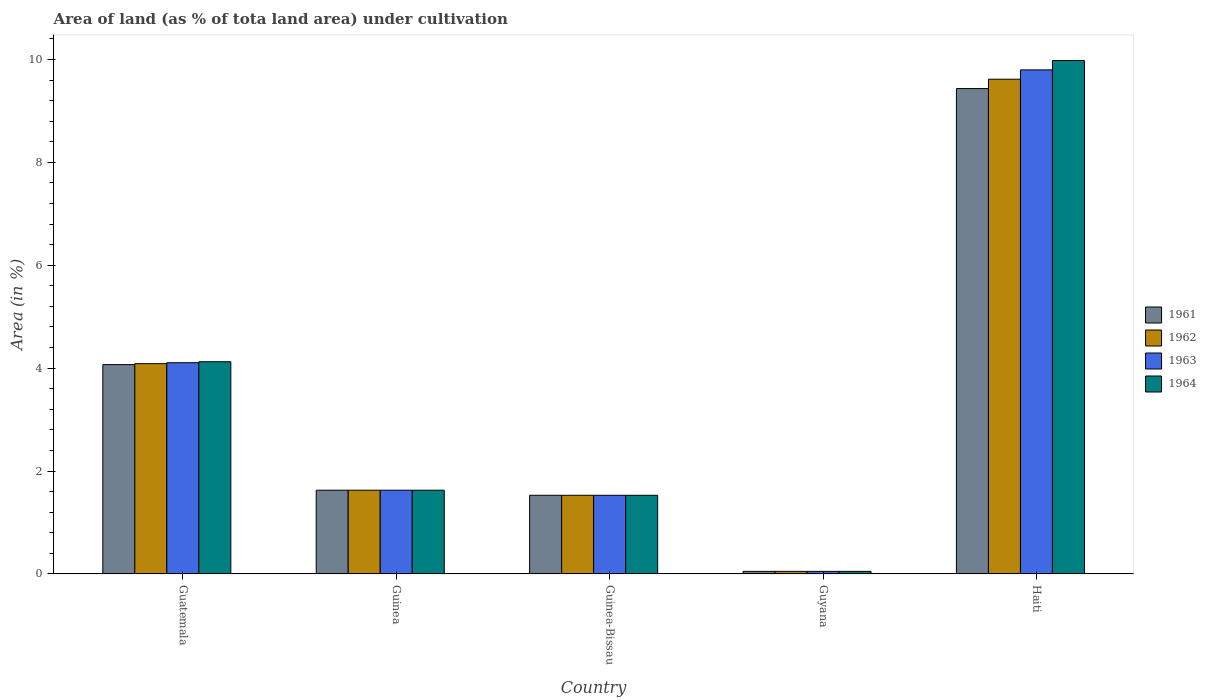Are the number of bars on each tick of the X-axis equal?
Offer a terse response. Yes. How many bars are there on the 2nd tick from the right?
Give a very brief answer. 4. What is the label of the 5th group of bars from the left?
Offer a terse response. Haiti. What is the percentage of land under cultivation in 1961 in Guinea-Bissau?
Your answer should be compact. 1.53. Across all countries, what is the maximum percentage of land under cultivation in 1962?
Your answer should be very brief. 9.62. Across all countries, what is the minimum percentage of land under cultivation in 1961?
Keep it short and to the point. 0.05. In which country was the percentage of land under cultivation in 1962 maximum?
Make the answer very short. Haiti. In which country was the percentage of land under cultivation in 1961 minimum?
Provide a short and direct response. Guyana. What is the total percentage of land under cultivation in 1962 in the graph?
Ensure brevity in your answer.  16.91. What is the difference between the percentage of land under cultivation in 1961 in Guinea and that in Haiti?
Keep it short and to the point. -7.81. What is the difference between the percentage of land under cultivation in 1962 in Guyana and the percentage of land under cultivation in 1964 in Guinea-Bissau?
Your response must be concise. -1.48. What is the average percentage of land under cultivation in 1963 per country?
Provide a short and direct response. 3.42. What is the difference between the percentage of land under cultivation of/in 1961 and percentage of land under cultivation of/in 1962 in Guatemala?
Give a very brief answer. -0.02. What is the ratio of the percentage of land under cultivation in 1964 in Guinea to that in Guyana?
Offer a terse response. 32.02. Is the difference between the percentage of land under cultivation in 1961 in Guinea and Haiti greater than the difference between the percentage of land under cultivation in 1962 in Guinea and Haiti?
Give a very brief answer. Yes. What is the difference between the highest and the second highest percentage of land under cultivation in 1964?
Your response must be concise. 5.85. What is the difference between the highest and the lowest percentage of land under cultivation in 1961?
Provide a succinct answer. 9.38. In how many countries, is the percentage of land under cultivation in 1961 greater than the average percentage of land under cultivation in 1961 taken over all countries?
Give a very brief answer. 2. Is it the case that in every country, the sum of the percentage of land under cultivation in 1962 and percentage of land under cultivation in 1961 is greater than the sum of percentage of land under cultivation in 1964 and percentage of land under cultivation in 1963?
Keep it short and to the point. No. Is it the case that in every country, the sum of the percentage of land under cultivation in 1963 and percentage of land under cultivation in 1964 is greater than the percentage of land under cultivation in 1961?
Offer a terse response. Yes. Does the graph contain any zero values?
Your answer should be very brief. No. What is the title of the graph?
Provide a short and direct response. Area of land (as % of tota land area) under cultivation. What is the label or title of the X-axis?
Provide a short and direct response. Country. What is the label or title of the Y-axis?
Keep it short and to the point. Area (in %). What is the Area (in %) of 1961 in Guatemala?
Your answer should be very brief. 4.07. What is the Area (in %) in 1962 in Guatemala?
Provide a succinct answer. 4.09. What is the Area (in %) in 1963 in Guatemala?
Give a very brief answer. 4.11. What is the Area (in %) in 1964 in Guatemala?
Keep it short and to the point. 4.12. What is the Area (in %) of 1961 in Guinea?
Ensure brevity in your answer.  1.63. What is the Area (in %) in 1962 in Guinea?
Ensure brevity in your answer.  1.63. What is the Area (in %) of 1963 in Guinea?
Keep it short and to the point. 1.63. What is the Area (in %) of 1964 in Guinea?
Offer a terse response. 1.63. What is the Area (in %) of 1961 in Guinea-Bissau?
Offer a very short reply. 1.53. What is the Area (in %) of 1962 in Guinea-Bissau?
Provide a succinct answer. 1.53. What is the Area (in %) of 1963 in Guinea-Bissau?
Your answer should be very brief. 1.53. What is the Area (in %) in 1964 in Guinea-Bissau?
Ensure brevity in your answer.  1.53. What is the Area (in %) in 1961 in Guyana?
Keep it short and to the point. 0.05. What is the Area (in %) in 1962 in Guyana?
Your answer should be compact. 0.05. What is the Area (in %) in 1963 in Guyana?
Offer a terse response. 0.05. What is the Area (in %) in 1964 in Guyana?
Offer a terse response. 0.05. What is the Area (in %) in 1961 in Haiti?
Ensure brevity in your answer.  9.43. What is the Area (in %) in 1962 in Haiti?
Offer a very short reply. 9.62. What is the Area (in %) of 1963 in Haiti?
Keep it short and to the point. 9.8. What is the Area (in %) in 1964 in Haiti?
Give a very brief answer. 9.98. Across all countries, what is the maximum Area (in %) of 1961?
Offer a very short reply. 9.43. Across all countries, what is the maximum Area (in %) of 1962?
Your response must be concise. 9.62. Across all countries, what is the maximum Area (in %) of 1963?
Your answer should be very brief. 9.8. Across all countries, what is the maximum Area (in %) in 1964?
Keep it short and to the point. 9.98. Across all countries, what is the minimum Area (in %) in 1961?
Provide a short and direct response. 0.05. Across all countries, what is the minimum Area (in %) in 1962?
Give a very brief answer. 0.05. Across all countries, what is the minimum Area (in %) of 1963?
Give a very brief answer. 0.05. Across all countries, what is the minimum Area (in %) in 1964?
Ensure brevity in your answer.  0.05. What is the total Area (in %) in 1961 in the graph?
Offer a very short reply. 16.71. What is the total Area (in %) of 1962 in the graph?
Provide a succinct answer. 16.91. What is the total Area (in %) of 1963 in the graph?
Offer a very short reply. 17.11. What is the total Area (in %) of 1964 in the graph?
Give a very brief answer. 17.31. What is the difference between the Area (in %) in 1961 in Guatemala and that in Guinea?
Give a very brief answer. 2.44. What is the difference between the Area (in %) of 1962 in Guatemala and that in Guinea?
Offer a very short reply. 2.46. What is the difference between the Area (in %) in 1963 in Guatemala and that in Guinea?
Your answer should be compact. 2.48. What is the difference between the Area (in %) in 1964 in Guatemala and that in Guinea?
Your answer should be very brief. 2.5. What is the difference between the Area (in %) of 1961 in Guatemala and that in Guinea-Bissau?
Offer a very short reply. 2.54. What is the difference between the Area (in %) in 1962 in Guatemala and that in Guinea-Bissau?
Give a very brief answer. 2.56. What is the difference between the Area (in %) in 1963 in Guatemala and that in Guinea-Bissau?
Offer a terse response. 2.58. What is the difference between the Area (in %) in 1964 in Guatemala and that in Guinea-Bissau?
Your answer should be compact. 2.6. What is the difference between the Area (in %) of 1961 in Guatemala and that in Guyana?
Provide a succinct answer. 4.02. What is the difference between the Area (in %) in 1962 in Guatemala and that in Guyana?
Your response must be concise. 4.04. What is the difference between the Area (in %) in 1963 in Guatemala and that in Guyana?
Your answer should be compact. 4.06. What is the difference between the Area (in %) of 1964 in Guatemala and that in Guyana?
Your response must be concise. 4.07. What is the difference between the Area (in %) of 1961 in Guatemala and that in Haiti?
Offer a terse response. -5.37. What is the difference between the Area (in %) in 1962 in Guatemala and that in Haiti?
Your answer should be very brief. -5.53. What is the difference between the Area (in %) in 1963 in Guatemala and that in Haiti?
Your answer should be compact. -5.69. What is the difference between the Area (in %) in 1964 in Guatemala and that in Haiti?
Offer a terse response. -5.85. What is the difference between the Area (in %) of 1961 in Guinea and that in Guinea-Bissau?
Give a very brief answer. 0.1. What is the difference between the Area (in %) of 1962 in Guinea and that in Guinea-Bissau?
Offer a terse response. 0.1. What is the difference between the Area (in %) in 1963 in Guinea and that in Guinea-Bissau?
Keep it short and to the point. 0.1. What is the difference between the Area (in %) of 1964 in Guinea and that in Guinea-Bissau?
Ensure brevity in your answer.  0.1. What is the difference between the Area (in %) in 1961 in Guinea and that in Guyana?
Provide a short and direct response. 1.58. What is the difference between the Area (in %) of 1962 in Guinea and that in Guyana?
Offer a very short reply. 1.58. What is the difference between the Area (in %) in 1963 in Guinea and that in Guyana?
Ensure brevity in your answer.  1.58. What is the difference between the Area (in %) of 1964 in Guinea and that in Guyana?
Ensure brevity in your answer.  1.58. What is the difference between the Area (in %) of 1961 in Guinea and that in Haiti?
Your answer should be very brief. -7.81. What is the difference between the Area (in %) in 1962 in Guinea and that in Haiti?
Offer a very short reply. -7.99. What is the difference between the Area (in %) of 1963 in Guinea and that in Haiti?
Your answer should be compact. -8.17. What is the difference between the Area (in %) of 1964 in Guinea and that in Haiti?
Give a very brief answer. -8.35. What is the difference between the Area (in %) in 1961 in Guinea-Bissau and that in Guyana?
Your answer should be very brief. 1.48. What is the difference between the Area (in %) of 1962 in Guinea-Bissau and that in Guyana?
Keep it short and to the point. 1.48. What is the difference between the Area (in %) in 1963 in Guinea-Bissau and that in Guyana?
Give a very brief answer. 1.48. What is the difference between the Area (in %) of 1964 in Guinea-Bissau and that in Guyana?
Your response must be concise. 1.48. What is the difference between the Area (in %) of 1961 in Guinea-Bissau and that in Haiti?
Keep it short and to the point. -7.9. What is the difference between the Area (in %) in 1962 in Guinea-Bissau and that in Haiti?
Your answer should be compact. -8.09. What is the difference between the Area (in %) in 1963 in Guinea-Bissau and that in Haiti?
Provide a succinct answer. -8.27. What is the difference between the Area (in %) of 1964 in Guinea-Bissau and that in Haiti?
Provide a succinct answer. -8.45. What is the difference between the Area (in %) of 1961 in Guyana and that in Haiti?
Your answer should be very brief. -9.38. What is the difference between the Area (in %) in 1962 in Guyana and that in Haiti?
Your response must be concise. -9.56. What is the difference between the Area (in %) of 1963 in Guyana and that in Haiti?
Make the answer very short. -9.75. What is the difference between the Area (in %) in 1964 in Guyana and that in Haiti?
Make the answer very short. -9.93. What is the difference between the Area (in %) in 1961 in Guatemala and the Area (in %) in 1962 in Guinea?
Offer a terse response. 2.44. What is the difference between the Area (in %) in 1961 in Guatemala and the Area (in %) in 1963 in Guinea?
Your answer should be very brief. 2.44. What is the difference between the Area (in %) of 1961 in Guatemala and the Area (in %) of 1964 in Guinea?
Give a very brief answer. 2.44. What is the difference between the Area (in %) in 1962 in Guatemala and the Area (in %) in 1963 in Guinea?
Offer a very short reply. 2.46. What is the difference between the Area (in %) in 1962 in Guatemala and the Area (in %) in 1964 in Guinea?
Your response must be concise. 2.46. What is the difference between the Area (in %) of 1963 in Guatemala and the Area (in %) of 1964 in Guinea?
Provide a short and direct response. 2.48. What is the difference between the Area (in %) of 1961 in Guatemala and the Area (in %) of 1962 in Guinea-Bissau?
Keep it short and to the point. 2.54. What is the difference between the Area (in %) of 1961 in Guatemala and the Area (in %) of 1963 in Guinea-Bissau?
Ensure brevity in your answer.  2.54. What is the difference between the Area (in %) in 1961 in Guatemala and the Area (in %) in 1964 in Guinea-Bissau?
Ensure brevity in your answer.  2.54. What is the difference between the Area (in %) in 1962 in Guatemala and the Area (in %) in 1963 in Guinea-Bissau?
Your response must be concise. 2.56. What is the difference between the Area (in %) of 1962 in Guatemala and the Area (in %) of 1964 in Guinea-Bissau?
Give a very brief answer. 2.56. What is the difference between the Area (in %) in 1963 in Guatemala and the Area (in %) in 1964 in Guinea-Bissau?
Make the answer very short. 2.58. What is the difference between the Area (in %) in 1961 in Guatemala and the Area (in %) in 1962 in Guyana?
Your response must be concise. 4.02. What is the difference between the Area (in %) in 1961 in Guatemala and the Area (in %) in 1963 in Guyana?
Offer a very short reply. 4.02. What is the difference between the Area (in %) of 1961 in Guatemala and the Area (in %) of 1964 in Guyana?
Ensure brevity in your answer.  4.02. What is the difference between the Area (in %) of 1962 in Guatemala and the Area (in %) of 1963 in Guyana?
Keep it short and to the point. 4.04. What is the difference between the Area (in %) in 1962 in Guatemala and the Area (in %) in 1964 in Guyana?
Offer a very short reply. 4.04. What is the difference between the Area (in %) in 1963 in Guatemala and the Area (in %) in 1964 in Guyana?
Make the answer very short. 4.06. What is the difference between the Area (in %) of 1961 in Guatemala and the Area (in %) of 1962 in Haiti?
Your answer should be very brief. -5.55. What is the difference between the Area (in %) in 1961 in Guatemala and the Area (in %) in 1963 in Haiti?
Offer a terse response. -5.73. What is the difference between the Area (in %) of 1961 in Guatemala and the Area (in %) of 1964 in Haiti?
Make the answer very short. -5.91. What is the difference between the Area (in %) in 1962 in Guatemala and the Area (in %) in 1963 in Haiti?
Offer a very short reply. -5.71. What is the difference between the Area (in %) of 1962 in Guatemala and the Area (in %) of 1964 in Haiti?
Offer a very short reply. -5.89. What is the difference between the Area (in %) in 1963 in Guatemala and the Area (in %) in 1964 in Haiti?
Keep it short and to the point. -5.87. What is the difference between the Area (in %) of 1961 in Guinea and the Area (in %) of 1962 in Guinea-Bissau?
Provide a short and direct response. 0.1. What is the difference between the Area (in %) of 1961 in Guinea and the Area (in %) of 1963 in Guinea-Bissau?
Provide a succinct answer. 0.1. What is the difference between the Area (in %) in 1961 in Guinea and the Area (in %) in 1964 in Guinea-Bissau?
Your answer should be very brief. 0.1. What is the difference between the Area (in %) in 1962 in Guinea and the Area (in %) in 1963 in Guinea-Bissau?
Give a very brief answer. 0.1. What is the difference between the Area (in %) in 1962 in Guinea and the Area (in %) in 1964 in Guinea-Bissau?
Offer a very short reply. 0.1. What is the difference between the Area (in %) in 1963 in Guinea and the Area (in %) in 1964 in Guinea-Bissau?
Ensure brevity in your answer.  0.1. What is the difference between the Area (in %) of 1961 in Guinea and the Area (in %) of 1962 in Guyana?
Keep it short and to the point. 1.58. What is the difference between the Area (in %) in 1961 in Guinea and the Area (in %) in 1963 in Guyana?
Provide a succinct answer. 1.58. What is the difference between the Area (in %) in 1961 in Guinea and the Area (in %) in 1964 in Guyana?
Make the answer very short. 1.58. What is the difference between the Area (in %) of 1962 in Guinea and the Area (in %) of 1963 in Guyana?
Keep it short and to the point. 1.58. What is the difference between the Area (in %) of 1962 in Guinea and the Area (in %) of 1964 in Guyana?
Keep it short and to the point. 1.58. What is the difference between the Area (in %) in 1963 in Guinea and the Area (in %) in 1964 in Guyana?
Ensure brevity in your answer.  1.58. What is the difference between the Area (in %) in 1961 in Guinea and the Area (in %) in 1962 in Haiti?
Keep it short and to the point. -7.99. What is the difference between the Area (in %) of 1961 in Guinea and the Area (in %) of 1963 in Haiti?
Offer a very short reply. -8.17. What is the difference between the Area (in %) in 1961 in Guinea and the Area (in %) in 1964 in Haiti?
Offer a very short reply. -8.35. What is the difference between the Area (in %) of 1962 in Guinea and the Area (in %) of 1963 in Haiti?
Give a very brief answer. -8.17. What is the difference between the Area (in %) of 1962 in Guinea and the Area (in %) of 1964 in Haiti?
Provide a succinct answer. -8.35. What is the difference between the Area (in %) of 1963 in Guinea and the Area (in %) of 1964 in Haiti?
Your answer should be very brief. -8.35. What is the difference between the Area (in %) in 1961 in Guinea-Bissau and the Area (in %) in 1962 in Guyana?
Offer a terse response. 1.48. What is the difference between the Area (in %) of 1961 in Guinea-Bissau and the Area (in %) of 1963 in Guyana?
Make the answer very short. 1.48. What is the difference between the Area (in %) of 1961 in Guinea-Bissau and the Area (in %) of 1964 in Guyana?
Offer a terse response. 1.48. What is the difference between the Area (in %) in 1962 in Guinea-Bissau and the Area (in %) in 1963 in Guyana?
Ensure brevity in your answer.  1.48. What is the difference between the Area (in %) in 1962 in Guinea-Bissau and the Area (in %) in 1964 in Guyana?
Give a very brief answer. 1.48. What is the difference between the Area (in %) of 1963 in Guinea-Bissau and the Area (in %) of 1964 in Guyana?
Make the answer very short. 1.48. What is the difference between the Area (in %) in 1961 in Guinea-Bissau and the Area (in %) in 1962 in Haiti?
Your answer should be very brief. -8.09. What is the difference between the Area (in %) in 1961 in Guinea-Bissau and the Area (in %) in 1963 in Haiti?
Offer a very short reply. -8.27. What is the difference between the Area (in %) in 1961 in Guinea-Bissau and the Area (in %) in 1964 in Haiti?
Your response must be concise. -8.45. What is the difference between the Area (in %) in 1962 in Guinea-Bissau and the Area (in %) in 1963 in Haiti?
Make the answer very short. -8.27. What is the difference between the Area (in %) in 1962 in Guinea-Bissau and the Area (in %) in 1964 in Haiti?
Your response must be concise. -8.45. What is the difference between the Area (in %) of 1963 in Guinea-Bissau and the Area (in %) of 1964 in Haiti?
Ensure brevity in your answer.  -8.45. What is the difference between the Area (in %) in 1961 in Guyana and the Area (in %) in 1962 in Haiti?
Offer a very short reply. -9.56. What is the difference between the Area (in %) of 1961 in Guyana and the Area (in %) of 1963 in Haiti?
Keep it short and to the point. -9.75. What is the difference between the Area (in %) in 1961 in Guyana and the Area (in %) in 1964 in Haiti?
Ensure brevity in your answer.  -9.93. What is the difference between the Area (in %) in 1962 in Guyana and the Area (in %) in 1963 in Haiti?
Provide a succinct answer. -9.75. What is the difference between the Area (in %) of 1962 in Guyana and the Area (in %) of 1964 in Haiti?
Make the answer very short. -9.93. What is the difference between the Area (in %) in 1963 in Guyana and the Area (in %) in 1964 in Haiti?
Give a very brief answer. -9.93. What is the average Area (in %) of 1961 per country?
Your response must be concise. 3.34. What is the average Area (in %) in 1962 per country?
Provide a succinct answer. 3.38. What is the average Area (in %) in 1963 per country?
Make the answer very short. 3.42. What is the average Area (in %) of 1964 per country?
Your response must be concise. 3.46. What is the difference between the Area (in %) of 1961 and Area (in %) of 1962 in Guatemala?
Your answer should be compact. -0.02. What is the difference between the Area (in %) in 1961 and Area (in %) in 1963 in Guatemala?
Give a very brief answer. -0.04. What is the difference between the Area (in %) in 1961 and Area (in %) in 1964 in Guatemala?
Keep it short and to the point. -0.06. What is the difference between the Area (in %) of 1962 and Area (in %) of 1963 in Guatemala?
Your response must be concise. -0.02. What is the difference between the Area (in %) of 1962 and Area (in %) of 1964 in Guatemala?
Provide a short and direct response. -0.04. What is the difference between the Area (in %) of 1963 and Area (in %) of 1964 in Guatemala?
Offer a very short reply. -0.02. What is the difference between the Area (in %) of 1961 and Area (in %) of 1962 in Guinea?
Your answer should be compact. 0. What is the difference between the Area (in %) of 1963 and Area (in %) of 1964 in Guinea?
Make the answer very short. 0. What is the difference between the Area (in %) of 1961 and Area (in %) of 1962 in Guinea-Bissau?
Ensure brevity in your answer.  0. What is the difference between the Area (in %) of 1961 and Area (in %) of 1963 in Guinea-Bissau?
Your answer should be very brief. 0. What is the difference between the Area (in %) of 1961 and Area (in %) of 1962 in Guyana?
Make the answer very short. 0. What is the difference between the Area (in %) of 1961 and Area (in %) of 1963 in Guyana?
Your response must be concise. 0. What is the difference between the Area (in %) in 1962 and Area (in %) in 1963 in Guyana?
Provide a succinct answer. 0. What is the difference between the Area (in %) of 1962 and Area (in %) of 1964 in Guyana?
Offer a terse response. 0. What is the difference between the Area (in %) of 1963 and Area (in %) of 1964 in Guyana?
Ensure brevity in your answer.  0. What is the difference between the Area (in %) of 1961 and Area (in %) of 1962 in Haiti?
Your answer should be compact. -0.18. What is the difference between the Area (in %) in 1961 and Area (in %) in 1963 in Haiti?
Your response must be concise. -0.36. What is the difference between the Area (in %) in 1961 and Area (in %) in 1964 in Haiti?
Offer a very short reply. -0.54. What is the difference between the Area (in %) in 1962 and Area (in %) in 1963 in Haiti?
Make the answer very short. -0.18. What is the difference between the Area (in %) of 1962 and Area (in %) of 1964 in Haiti?
Your answer should be very brief. -0.36. What is the difference between the Area (in %) of 1963 and Area (in %) of 1964 in Haiti?
Ensure brevity in your answer.  -0.18. What is the ratio of the Area (in %) in 1961 in Guatemala to that in Guinea?
Ensure brevity in your answer.  2.5. What is the ratio of the Area (in %) in 1962 in Guatemala to that in Guinea?
Offer a very short reply. 2.51. What is the ratio of the Area (in %) in 1963 in Guatemala to that in Guinea?
Offer a terse response. 2.52. What is the ratio of the Area (in %) in 1964 in Guatemala to that in Guinea?
Provide a succinct answer. 2.53. What is the ratio of the Area (in %) of 1961 in Guatemala to that in Guinea-Bissau?
Keep it short and to the point. 2.66. What is the ratio of the Area (in %) in 1962 in Guatemala to that in Guinea-Bissau?
Your answer should be very brief. 2.67. What is the ratio of the Area (in %) in 1963 in Guatemala to that in Guinea-Bissau?
Offer a terse response. 2.69. What is the ratio of the Area (in %) in 1964 in Guatemala to that in Guinea-Bissau?
Your response must be concise. 2.7. What is the ratio of the Area (in %) in 1961 in Guatemala to that in Guyana?
Provide a short and direct response. 80.04. What is the ratio of the Area (in %) in 1962 in Guatemala to that in Guyana?
Make the answer very short. 80.4. What is the ratio of the Area (in %) in 1963 in Guatemala to that in Guyana?
Ensure brevity in your answer.  80.77. What is the ratio of the Area (in %) in 1964 in Guatemala to that in Guyana?
Offer a very short reply. 81.14. What is the ratio of the Area (in %) in 1961 in Guatemala to that in Haiti?
Offer a very short reply. 0.43. What is the ratio of the Area (in %) of 1962 in Guatemala to that in Haiti?
Provide a succinct answer. 0.43. What is the ratio of the Area (in %) of 1963 in Guatemala to that in Haiti?
Offer a very short reply. 0.42. What is the ratio of the Area (in %) of 1964 in Guatemala to that in Haiti?
Keep it short and to the point. 0.41. What is the ratio of the Area (in %) of 1961 in Guinea to that in Guinea-Bissau?
Provide a short and direct response. 1.06. What is the ratio of the Area (in %) in 1962 in Guinea to that in Guinea-Bissau?
Make the answer very short. 1.06. What is the ratio of the Area (in %) in 1963 in Guinea to that in Guinea-Bissau?
Provide a succinct answer. 1.06. What is the ratio of the Area (in %) of 1964 in Guinea to that in Guinea-Bissau?
Your answer should be very brief. 1.06. What is the ratio of the Area (in %) in 1961 in Guinea to that in Guyana?
Make the answer very short. 32.02. What is the ratio of the Area (in %) of 1962 in Guinea to that in Guyana?
Make the answer very short. 32.02. What is the ratio of the Area (in %) in 1963 in Guinea to that in Guyana?
Make the answer very short. 32.02. What is the ratio of the Area (in %) in 1964 in Guinea to that in Guyana?
Make the answer very short. 32.02. What is the ratio of the Area (in %) in 1961 in Guinea to that in Haiti?
Ensure brevity in your answer.  0.17. What is the ratio of the Area (in %) of 1962 in Guinea to that in Haiti?
Offer a terse response. 0.17. What is the ratio of the Area (in %) in 1963 in Guinea to that in Haiti?
Your answer should be compact. 0.17. What is the ratio of the Area (in %) of 1964 in Guinea to that in Haiti?
Your answer should be very brief. 0.16. What is the ratio of the Area (in %) of 1961 in Guinea-Bissau to that in Guyana?
Offer a terse response. 30.08. What is the ratio of the Area (in %) of 1962 in Guinea-Bissau to that in Guyana?
Make the answer very short. 30.08. What is the ratio of the Area (in %) in 1963 in Guinea-Bissau to that in Guyana?
Your response must be concise. 30.08. What is the ratio of the Area (in %) in 1964 in Guinea-Bissau to that in Guyana?
Offer a very short reply. 30.08. What is the ratio of the Area (in %) in 1961 in Guinea-Bissau to that in Haiti?
Offer a very short reply. 0.16. What is the ratio of the Area (in %) in 1962 in Guinea-Bissau to that in Haiti?
Give a very brief answer. 0.16. What is the ratio of the Area (in %) in 1963 in Guinea-Bissau to that in Haiti?
Offer a very short reply. 0.16. What is the ratio of the Area (in %) in 1964 in Guinea-Bissau to that in Haiti?
Ensure brevity in your answer.  0.15. What is the ratio of the Area (in %) of 1961 in Guyana to that in Haiti?
Provide a succinct answer. 0.01. What is the ratio of the Area (in %) of 1962 in Guyana to that in Haiti?
Provide a succinct answer. 0.01. What is the ratio of the Area (in %) of 1963 in Guyana to that in Haiti?
Your answer should be compact. 0.01. What is the ratio of the Area (in %) of 1964 in Guyana to that in Haiti?
Provide a short and direct response. 0.01. What is the difference between the highest and the second highest Area (in %) in 1961?
Offer a terse response. 5.37. What is the difference between the highest and the second highest Area (in %) in 1962?
Keep it short and to the point. 5.53. What is the difference between the highest and the second highest Area (in %) of 1963?
Keep it short and to the point. 5.69. What is the difference between the highest and the second highest Area (in %) of 1964?
Your answer should be very brief. 5.85. What is the difference between the highest and the lowest Area (in %) of 1961?
Offer a terse response. 9.38. What is the difference between the highest and the lowest Area (in %) of 1962?
Make the answer very short. 9.56. What is the difference between the highest and the lowest Area (in %) of 1963?
Give a very brief answer. 9.75. What is the difference between the highest and the lowest Area (in %) in 1964?
Keep it short and to the point. 9.93. 